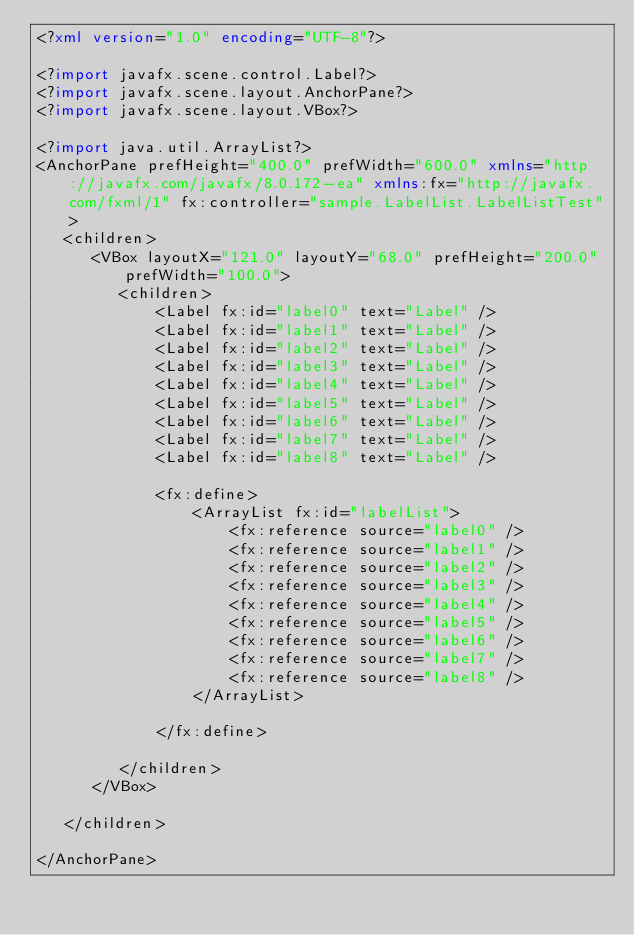<code> <loc_0><loc_0><loc_500><loc_500><_XML_><?xml version="1.0" encoding="UTF-8"?>

<?import javafx.scene.control.Label?>
<?import javafx.scene.layout.AnchorPane?>
<?import javafx.scene.layout.VBox?>

<?import java.util.ArrayList?>
<AnchorPane prefHeight="400.0" prefWidth="600.0" xmlns="http://javafx.com/javafx/8.0.172-ea" xmlns:fx="http://javafx.com/fxml/1" fx:controller="sample.LabelList.LabelListTest">
   <children>
      <VBox layoutX="121.0" layoutY="68.0" prefHeight="200.0" prefWidth="100.0">
         <children>
             <Label fx:id="label0" text="Label" />
             <Label fx:id="label1" text="Label" />
             <Label fx:id="label2" text="Label" />
             <Label fx:id="label3" text="Label" />
             <Label fx:id="label4" text="Label" />
             <Label fx:id="label5" text="Label" />
             <Label fx:id="label6" text="Label" />
             <Label fx:id="label7" text="Label" />
             <Label fx:id="label8" text="Label" />

             <fx:define>
                 <ArrayList fx:id="labelList">
                     <fx:reference source="label0" />
                     <fx:reference source="label1" />
                     <fx:reference source="label2" />
                     <fx:reference source="label3" />
                     <fx:reference source="label4" />
                     <fx:reference source="label5" />
                     <fx:reference source="label6" />
                     <fx:reference source="label7" />
                     <fx:reference source="label8" />
                 </ArrayList>

             </fx:define>

         </children>
      </VBox>

   </children>

</AnchorPane>
</code> 